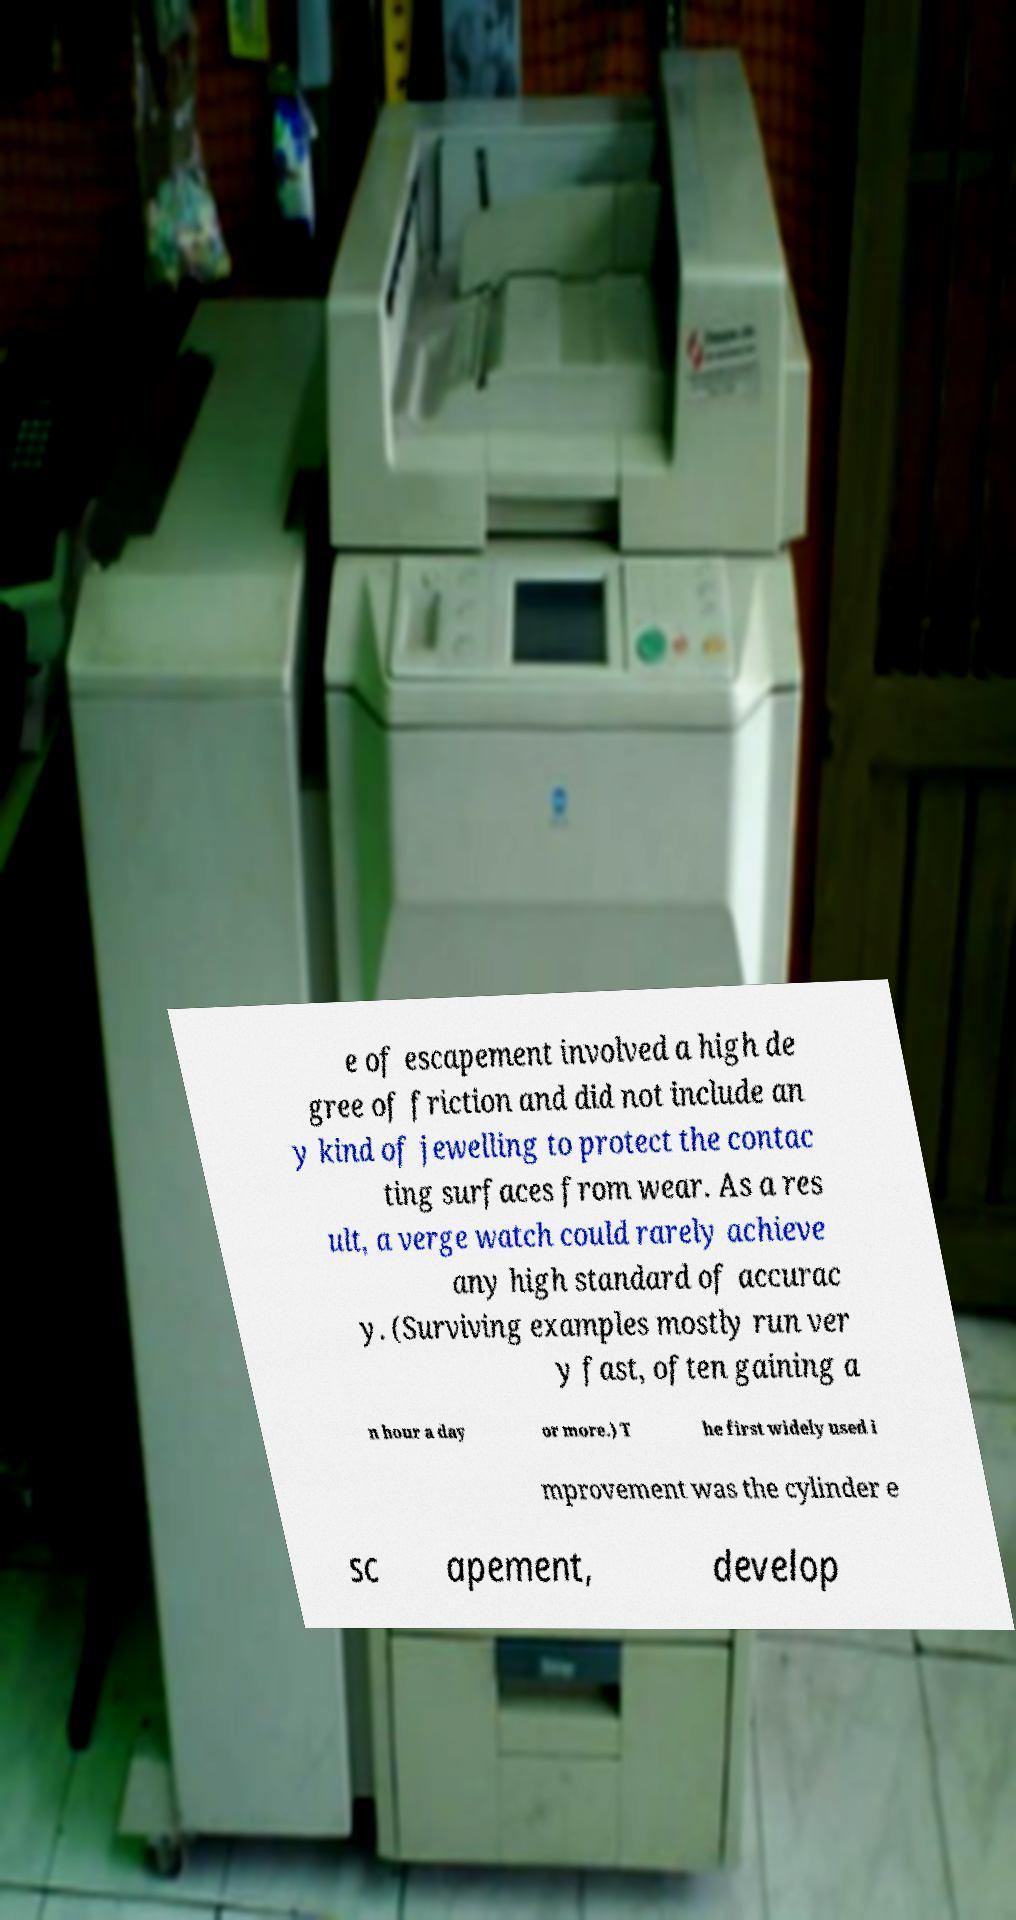Can you read and provide the text displayed in the image?This photo seems to have some interesting text. Can you extract and type it out for me? e of escapement involved a high de gree of friction and did not include an y kind of jewelling to protect the contac ting surfaces from wear. As a res ult, a verge watch could rarely achieve any high standard of accurac y. (Surviving examples mostly run ver y fast, often gaining a n hour a day or more.) T he first widely used i mprovement was the cylinder e sc apement, develop 